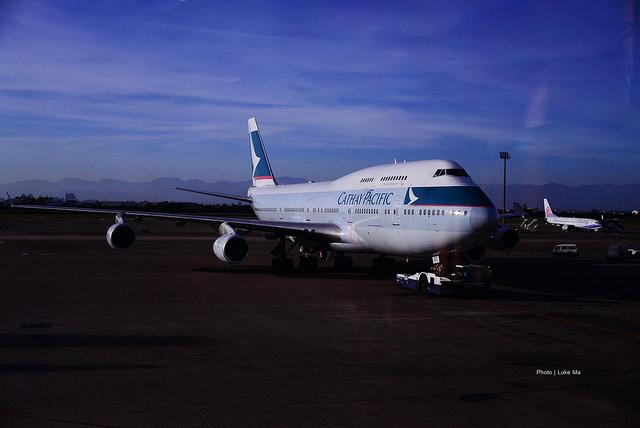Are the wheels chocked?
Be succinct. No. How many colors is the plane's tail?
Give a very brief answer. 3. What is on the runway?a?
Keep it brief. Airplane. What airlines is this plane with?
Write a very short answer. Pacific. Is this an old photograph?
Keep it brief. No. 